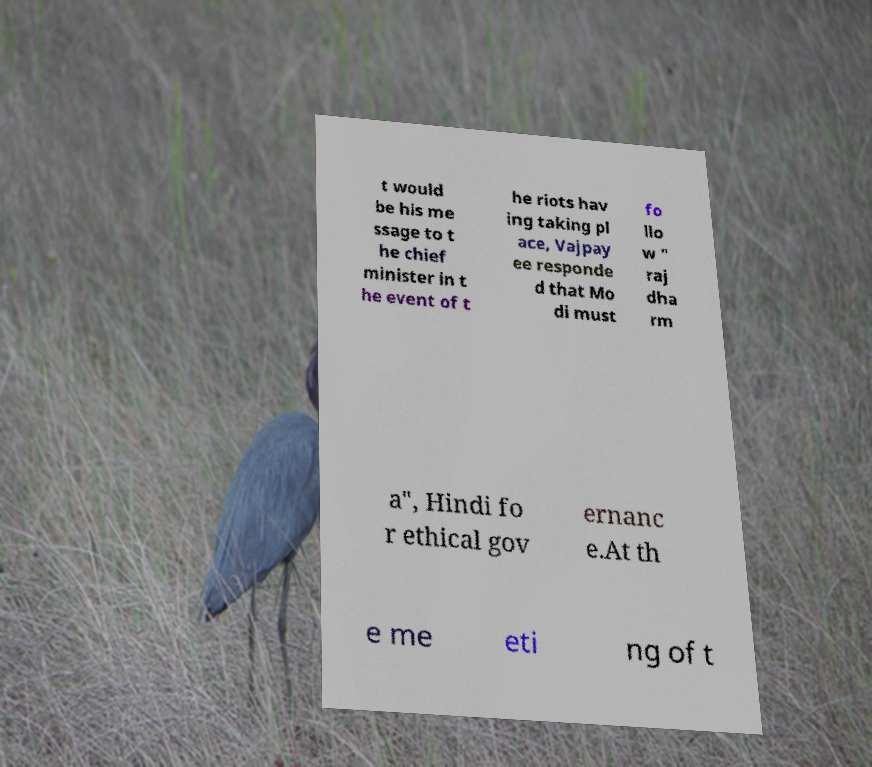For documentation purposes, I need the text within this image transcribed. Could you provide that? t would be his me ssage to t he chief minister in t he event of t he riots hav ing taking pl ace, Vajpay ee responde d that Mo di must fo llo w " raj dha rm a", Hindi fo r ethical gov ernanc e.At th e me eti ng of t 